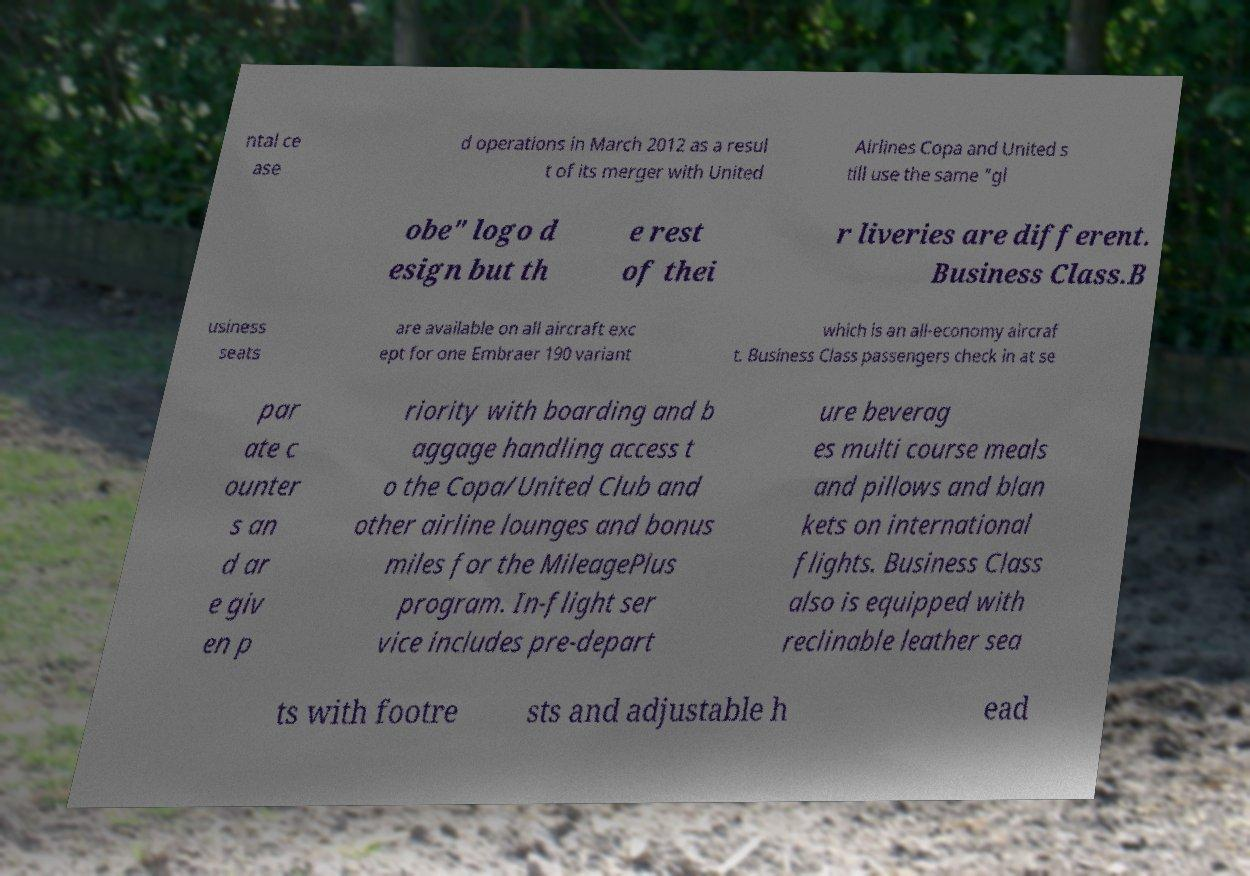For documentation purposes, I need the text within this image transcribed. Could you provide that? ntal ce ase d operations in March 2012 as a resul t of its merger with United Airlines Copa and United s till use the same "gl obe" logo d esign but th e rest of thei r liveries are different. Business Class.B usiness seats are available on all aircraft exc ept for one Embraer 190 variant which is an all-economy aircraf t. Business Class passengers check in at se par ate c ounter s an d ar e giv en p riority with boarding and b aggage handling access t o the Copa/United Club and other airline lounges and bonus miles for the MileagePlus program. In-flight ser vice includes pre-depart ure beverag es multi course meals and pillows and blan kets on international flights. Business Class also is equipped with reclinable leather sea ts with footre sts and adjustable h ead 